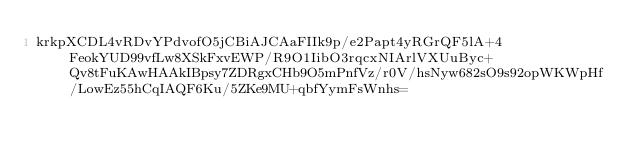Convert code to text. <code><loc_0><loc_0><loc_500><loc_500><_SML_>krkpXCDL4vRDvYPdvofO5jCBiAJCAaFIIk9p/e2Papt4yRGrQF5lA+4FeokYUD99vfLw8XSkFxvEWP/R9O1IibO3rqcxNIArlVXUuByc+Qv8tFuKAwHAAkIBpsy7ZDRgxCHb9O5mPnfVz/r0V/hsNyw682sO9s92opWKWpHf/LowEz55hCqIAQF6Ku/5ZKe9MU+qbfYymFsWnhs=</code> 